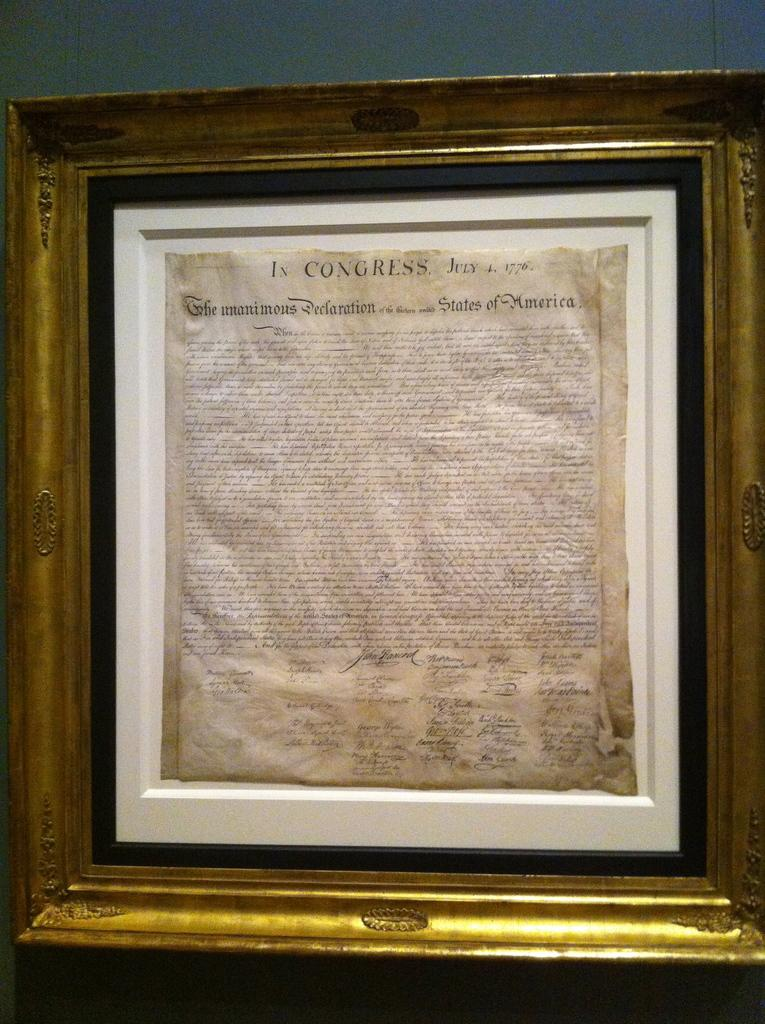<image>
Describe the image concisely. A frame holding the declaration of the United States of America. 